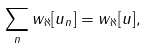<formula> <loc_0><loc_0><loc_500><loc_500>\sum _ { n } w _ { \aleph } [ u _ { n } ] = w _ { \aleph } [ u ] ,</formula> 